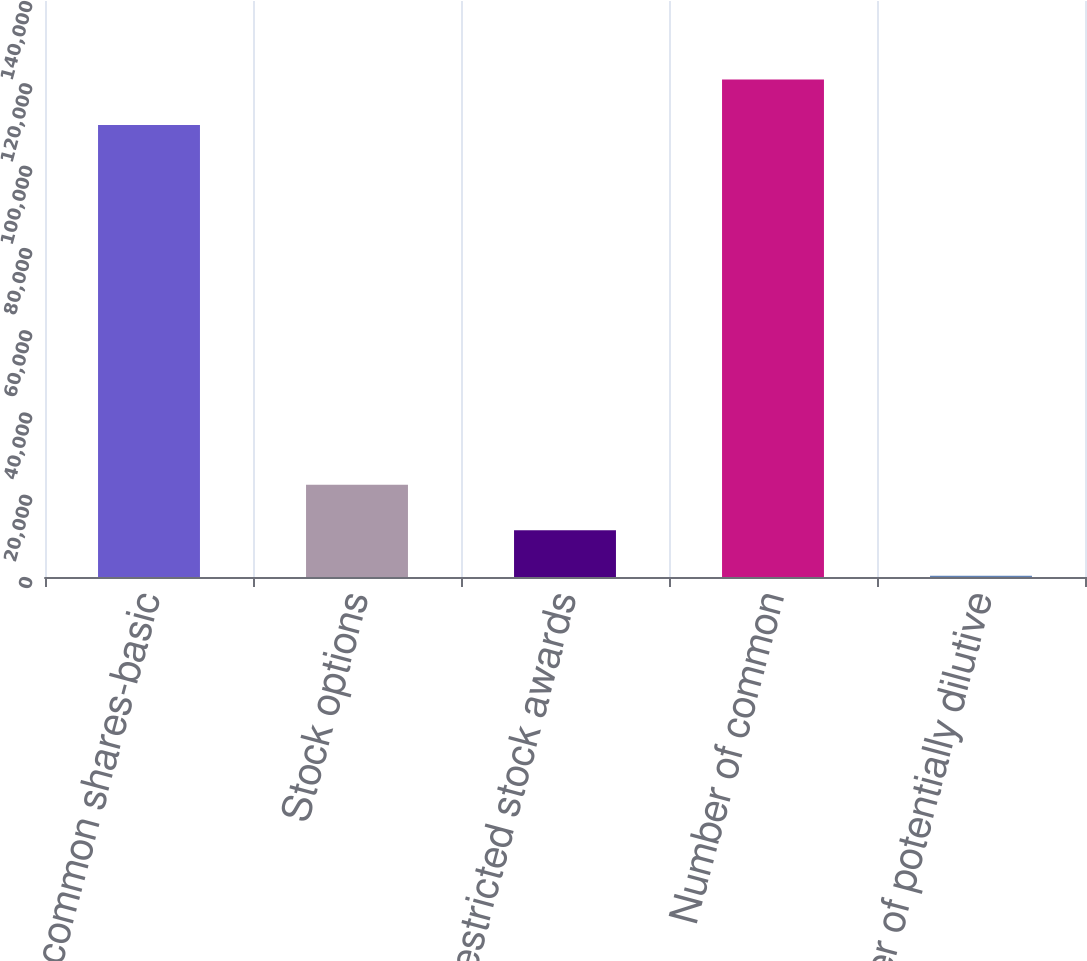<chart> <loc_0><loc_0><loc_500><loc_500><bar_chart><fcel>Number of common shares-basic<fcel>Stock options<fcel>Restricted stock awards<fcel>Number of common<fcel>Number of potentially dilutive<nl><fcel>109857<fcel>22401.4<fcel>11344.2<fcel>120914<fcel>287<nl></chart> 